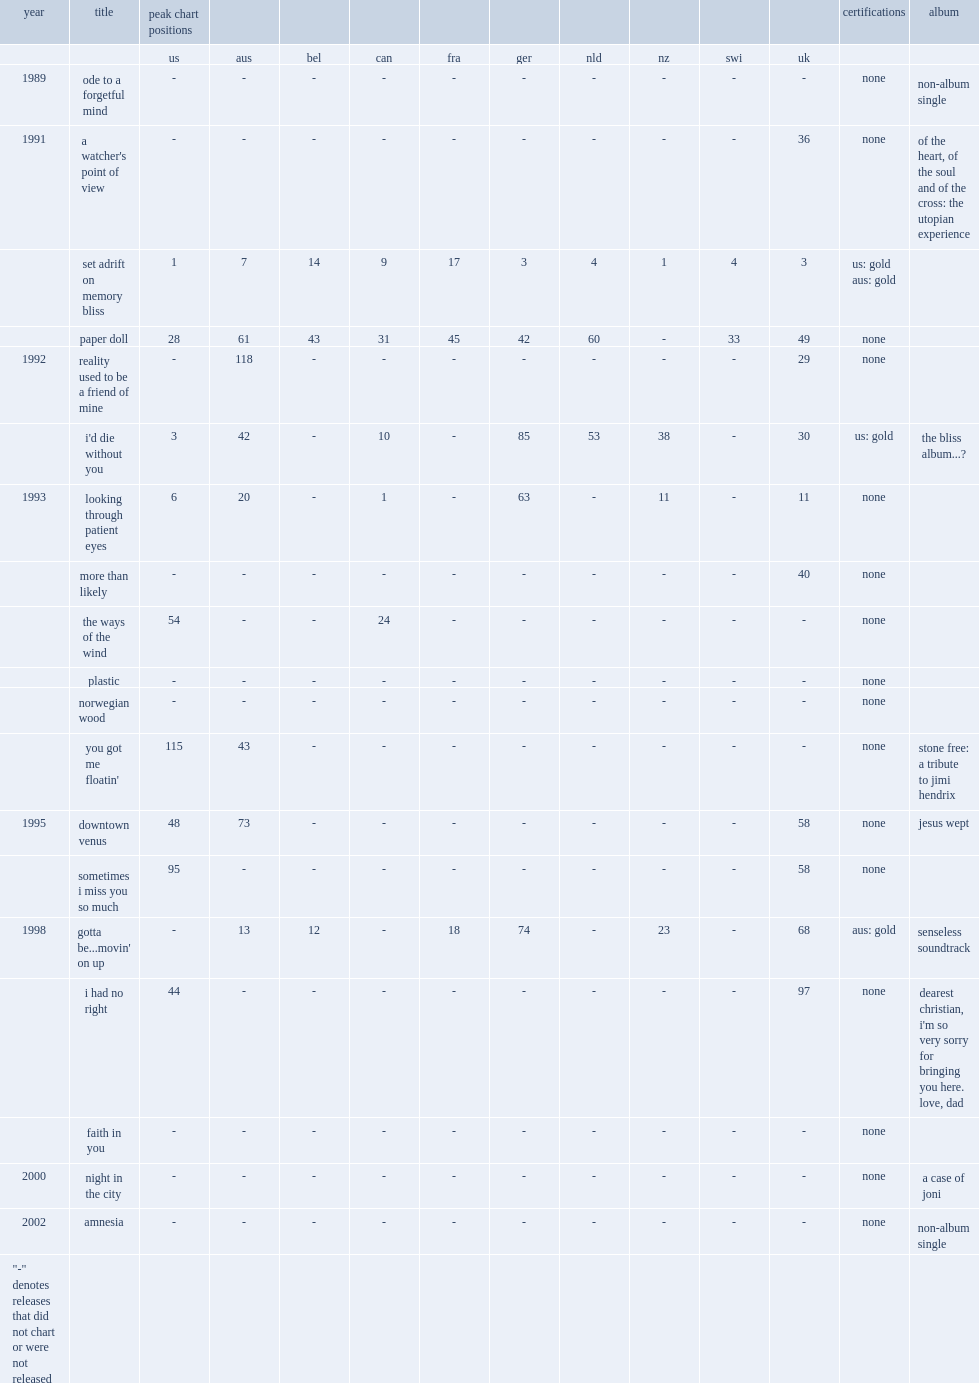Wen did dawn contribute the single, "you got me floatin", from the album stone free: a tribute to jimi hendrix? 1993.0. 